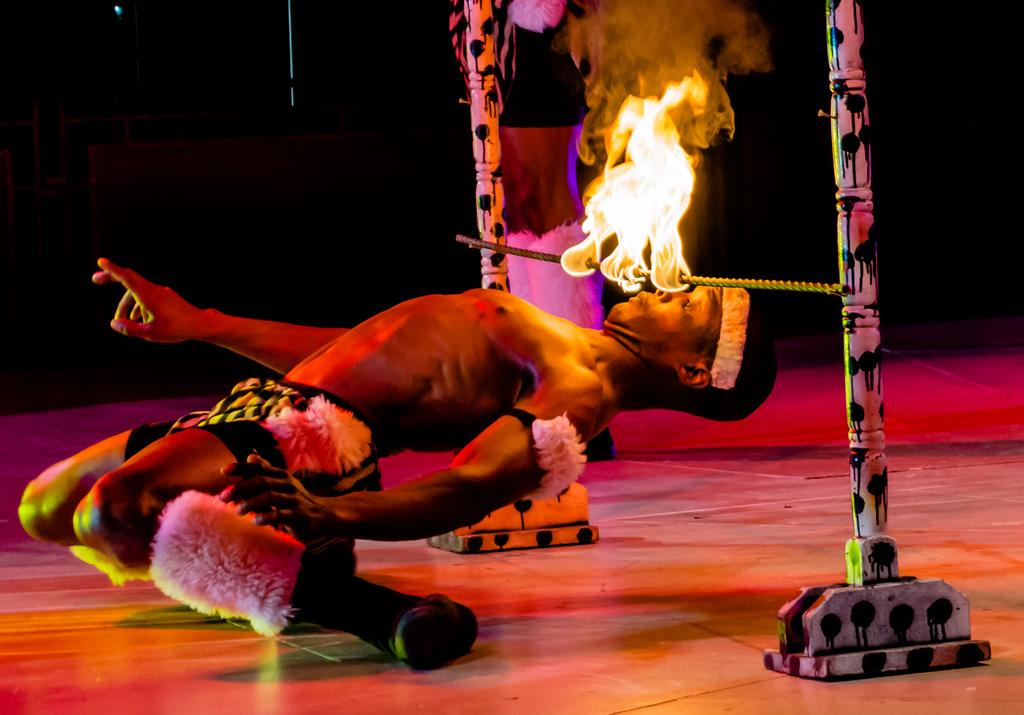What is the main subject of the image? There is a person in the image. What is the person doing in the image? The person is looking at a fire. How is the fire positioned in the image? The fire is on a rod. How is the rod supported in the image? The rod is attached to poles. What does the fire taste like in the image? The fire cannot be tasted in the image, as it is a visual representation and not a physical sensation. 